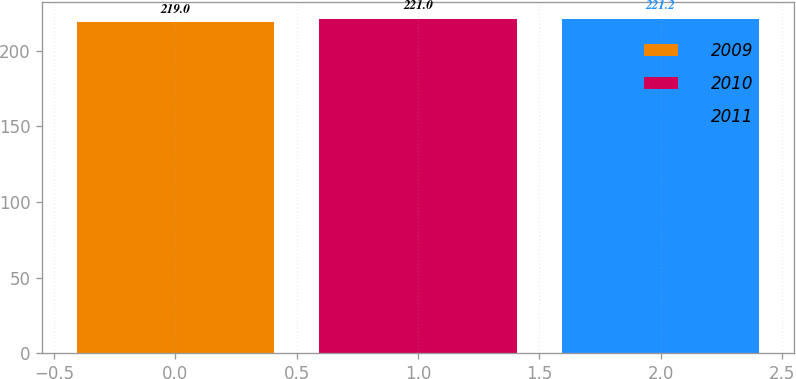Convert chart to OTSL. <chart><loc_0><loc_0><loc_500><loc_500><bar_chart><fcel>2009<fcel>2010<fcel>2011<nl><fcel>219<fcel>221<fcel>221.2<nl></chart> 